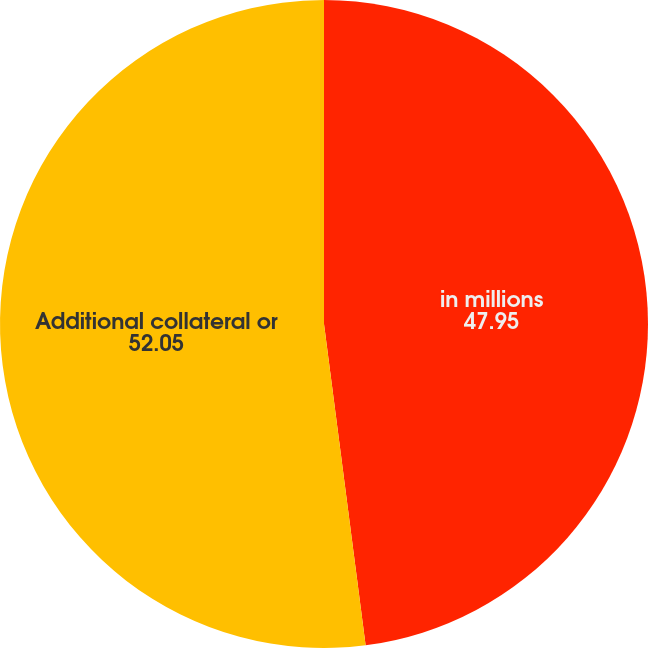Convert chart. <chart><loc_0><loc_0><loc_500><loc_500><pie_chart><fcel>in millions<fcel>Additional collateral or<nl><fcel>47.95%<fcel>52.05%<nl></chart> 